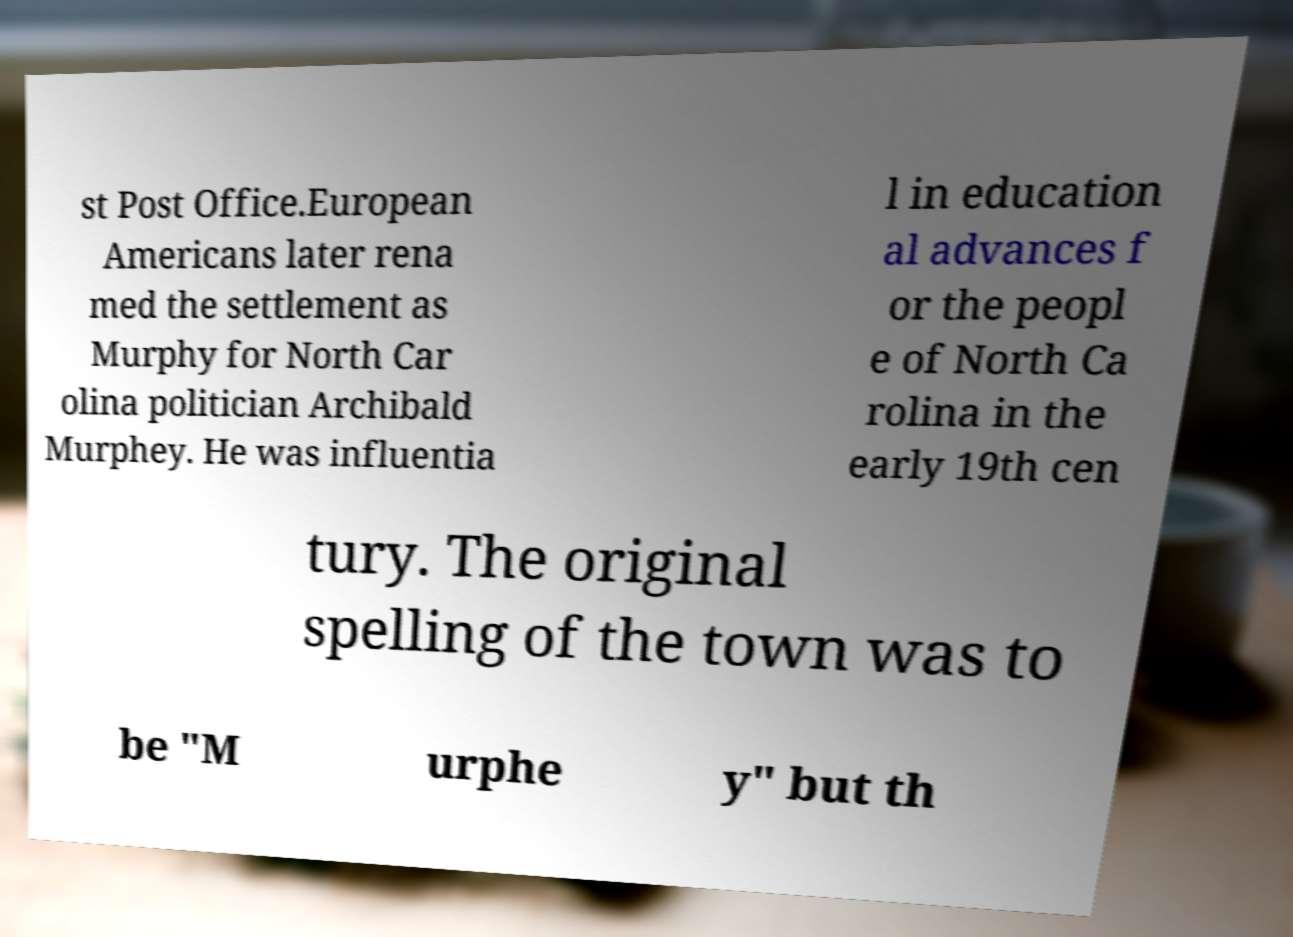Could you assist in decoding the text presented in this image and type it out clearly? st Post Office.European Americans later rena med the settlement as Murphy for North Car olina politician Archibald Murphey. He was influentia l in education al advances f or the peopl e of North Ca rolina in the early 19th cen tury. The original spelling of the town was to be "M urphe y" but th 